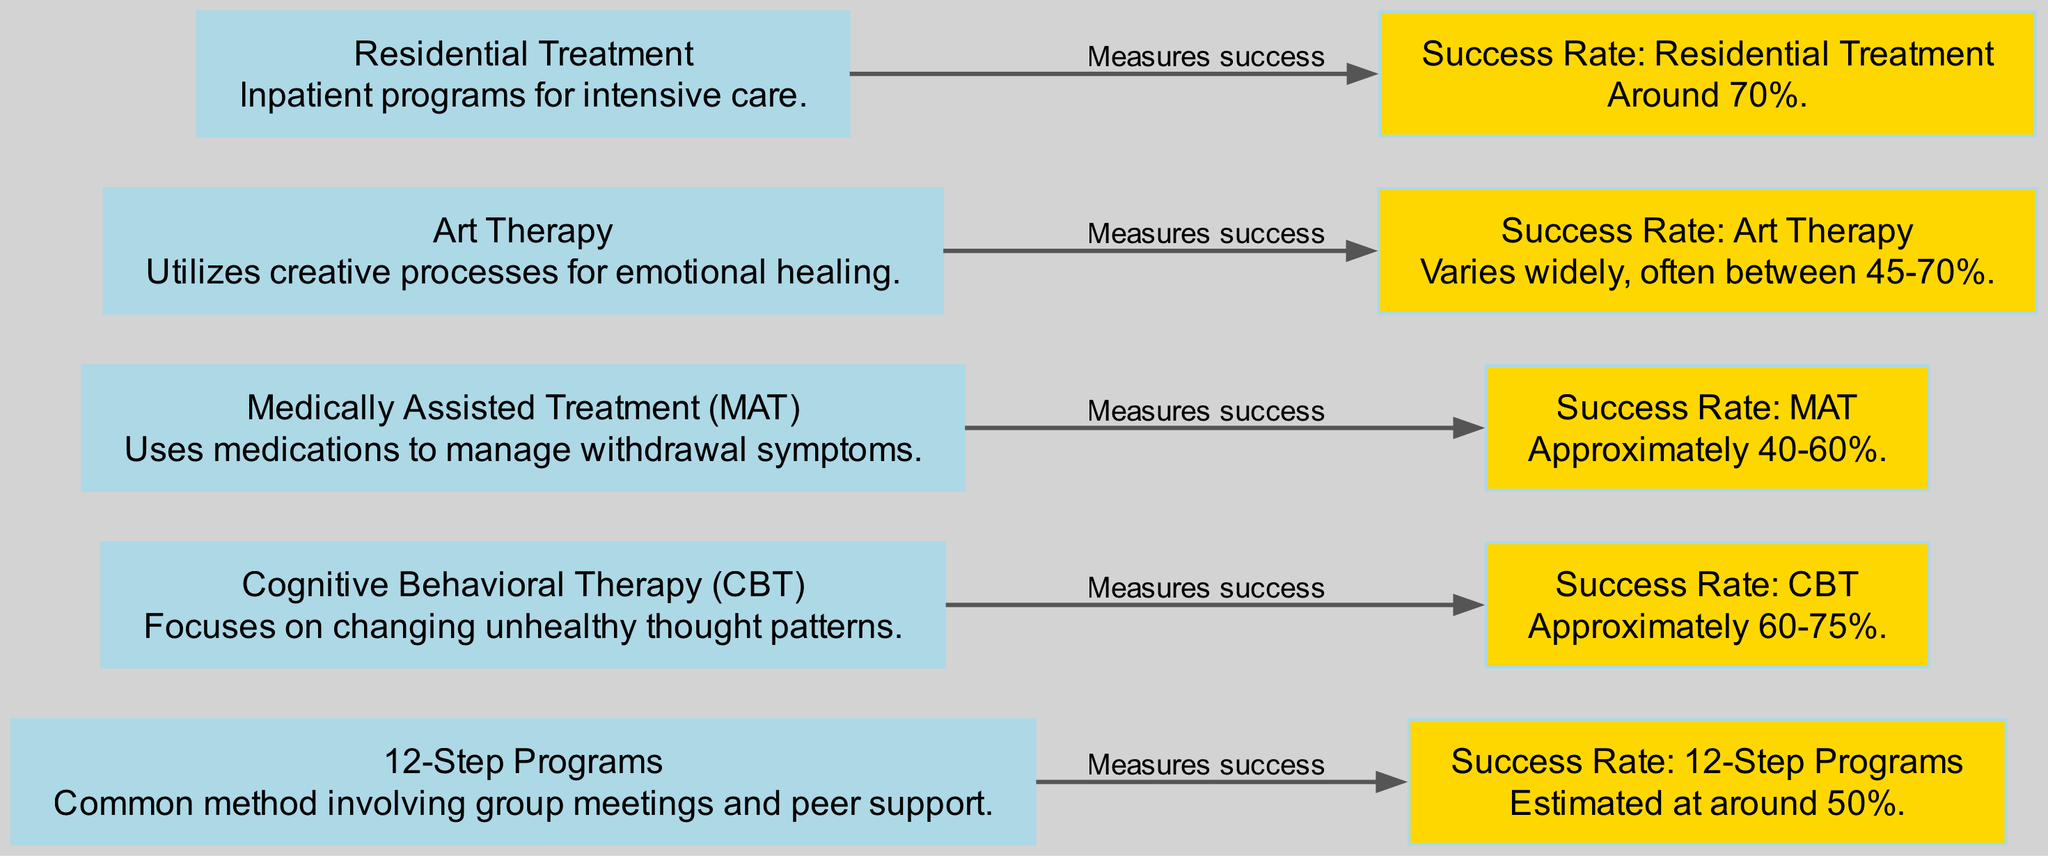What are the five addiction treatment methods listed in the diagram? The diagram includes five nodes representing treatment methods: 12-Step Programs, Cognitive Behavioral Therapy, Medically Assisted Treatment, Art Therapy, and Residential Treatment. These methods are visually distinct nodes directly indicated in the diagram layout.
Answer: 12-Step Programs, Cognitive Behavioral Therapy, Medically Assisted Treatment, Art Therapy, Residential Treatment What is the success rate of Residential Treatment? According to the diagram, the success rate for Residential Treatment is indicated as around 70%. This information is provided in a direct node connected to the Residential Treatment method through an edge labeled "Measures success."
Answer: Around 70% Which treatment method has a success rate between 60-75%? The diagram specifies that Cognitive Behavioral Therapy has a success rate that falls within the range of 60-75%. This information links the method to its success rate through the directed edge denoting success measurement.
Answer: Cognitive Behavioral Therapy How many treatment methods have a success rate mentioned in the diagram? The diagram lists five treatment methods, each connected to a success rate node, indicating that all five have a corresponding success rate. Each treatment method is directly associated with a success rate node through directed edges.
Answer: Five Which method utilizes creative processes for emotional healing? The diagram associates Art Therapy with the description of utilizing creative processes for emotional healing. This is clearly stated in the node summarized next to the method itself.
Answer: Art Therapy What is the success rate range of Art Therapy? The diagram shows that the success rate of Art Therapy varies widely, often between 45% and 70%. The connection between the Art Therapy method and its success rate is made clear through the directed edge labeled "Measures success."
Answer: 45-70% Which treatment has the lowest estimated success rate? From the information in the diagram, Medically Assisted Treatment has the lowest estimated success rate, falling in the range of approximately 40-60%, as indicated in the corresponding node linked to the method.
Answer: Approximately 40-60% How many nodes in the diagram represent success rates? There are five nodes in the diagram that represent success rates. Each success rate node is connected to its respective treatment method, indicating a direct relationship with the treatment’s effectiveness.
Answer: Five What is the estimated success rate of 12-Step Programs? The diagram indicates that the estimated success rate of 12-Step Programs is around 50%. This link is established through a direct edge from the treatment method node to its success rate node.
Answer: Around 50% 